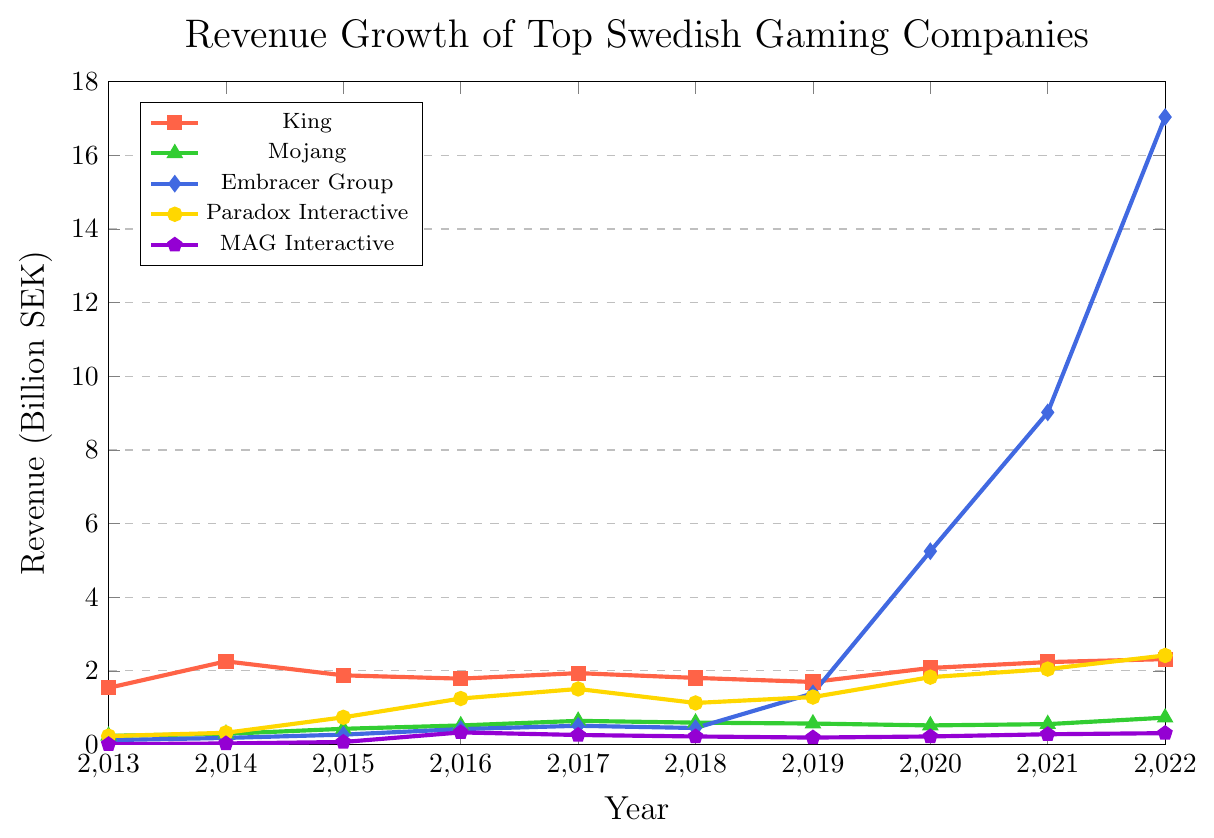What is the revenue growth trend for the company "King" from 2013 to 2022? To understand the trend, look at the points connected by the line representing "King" and observe whether the revenue is generally increasing, decreasing, or fluctuating over time. King’s revenue generally hovers just above 1.5 billion SEK, with minor fluctuations and a slight increase toward the end of the period. The trend shows a slight upward trajectory overall.
Answer: Slight upward trajectory Which company had the highest revenue in 2022? Observe the endpoints of all the lines at the year 2022 and compare their heights. The endpoint for Embracer Group is the highest in 2022.
Answer: Embracer Group How does the revenue growth of Paradox Interactive in 2022 compare to its growth in 2013? Compare the heights of the mark for Paradox Interactive in 2022 and 2013. Paradox Interactive’s revenue in 2022 (2.42 billion SEK) is significantly higher than in 2013 (0.23 billion SEK).
Answer: Higher Which company experienced the most dramatic revenue growth between 2019 and 2022? Compare the vertical distance (difference) between the points of all companies from 2019 to 2022. Embracer Group's revenue grew dramatically from 1.39 billion SEK in 2019 to 17.04 billion SEK in 2022, showing the most notable increase.
Answer: Embracer Group What color represents the company Mojang in the chart? Check the legend for the color assigned to Mojang, which is green.
Answer: Green Calculate the average revenue of Mojang over the decade from 2013 to 2022. Sum the revenue values for Mojang from each year and divide by the number of years: (0.237 + 0.291 + 0.428 + 0.519 + 0.644 + 0.595 + 0.571 + 0.520 + 0.555 + 0.731) / 10 ≈ 0.5091 billion SEK.
Answer: 0.5091 billion SEK Between which two consecutive years did King experience its highest revenue increase? Check the differences in King’s revenue between consecutive years and identify the greatest difference. King’s highest revenue increase occurred between 2013 (1.54 billion SEK) and 2014 (2.26 billion SEK).
Answer: 2013-2014 By how much did the revenue of MAG Interactive increase from 2015 to 2016? Subtract MAG Interactive’s revenue in 2015 from the revenue in 2016: 0.33 - 0.07 = 0.26 billion SEK.
Answer: 0.26 billion SEK 